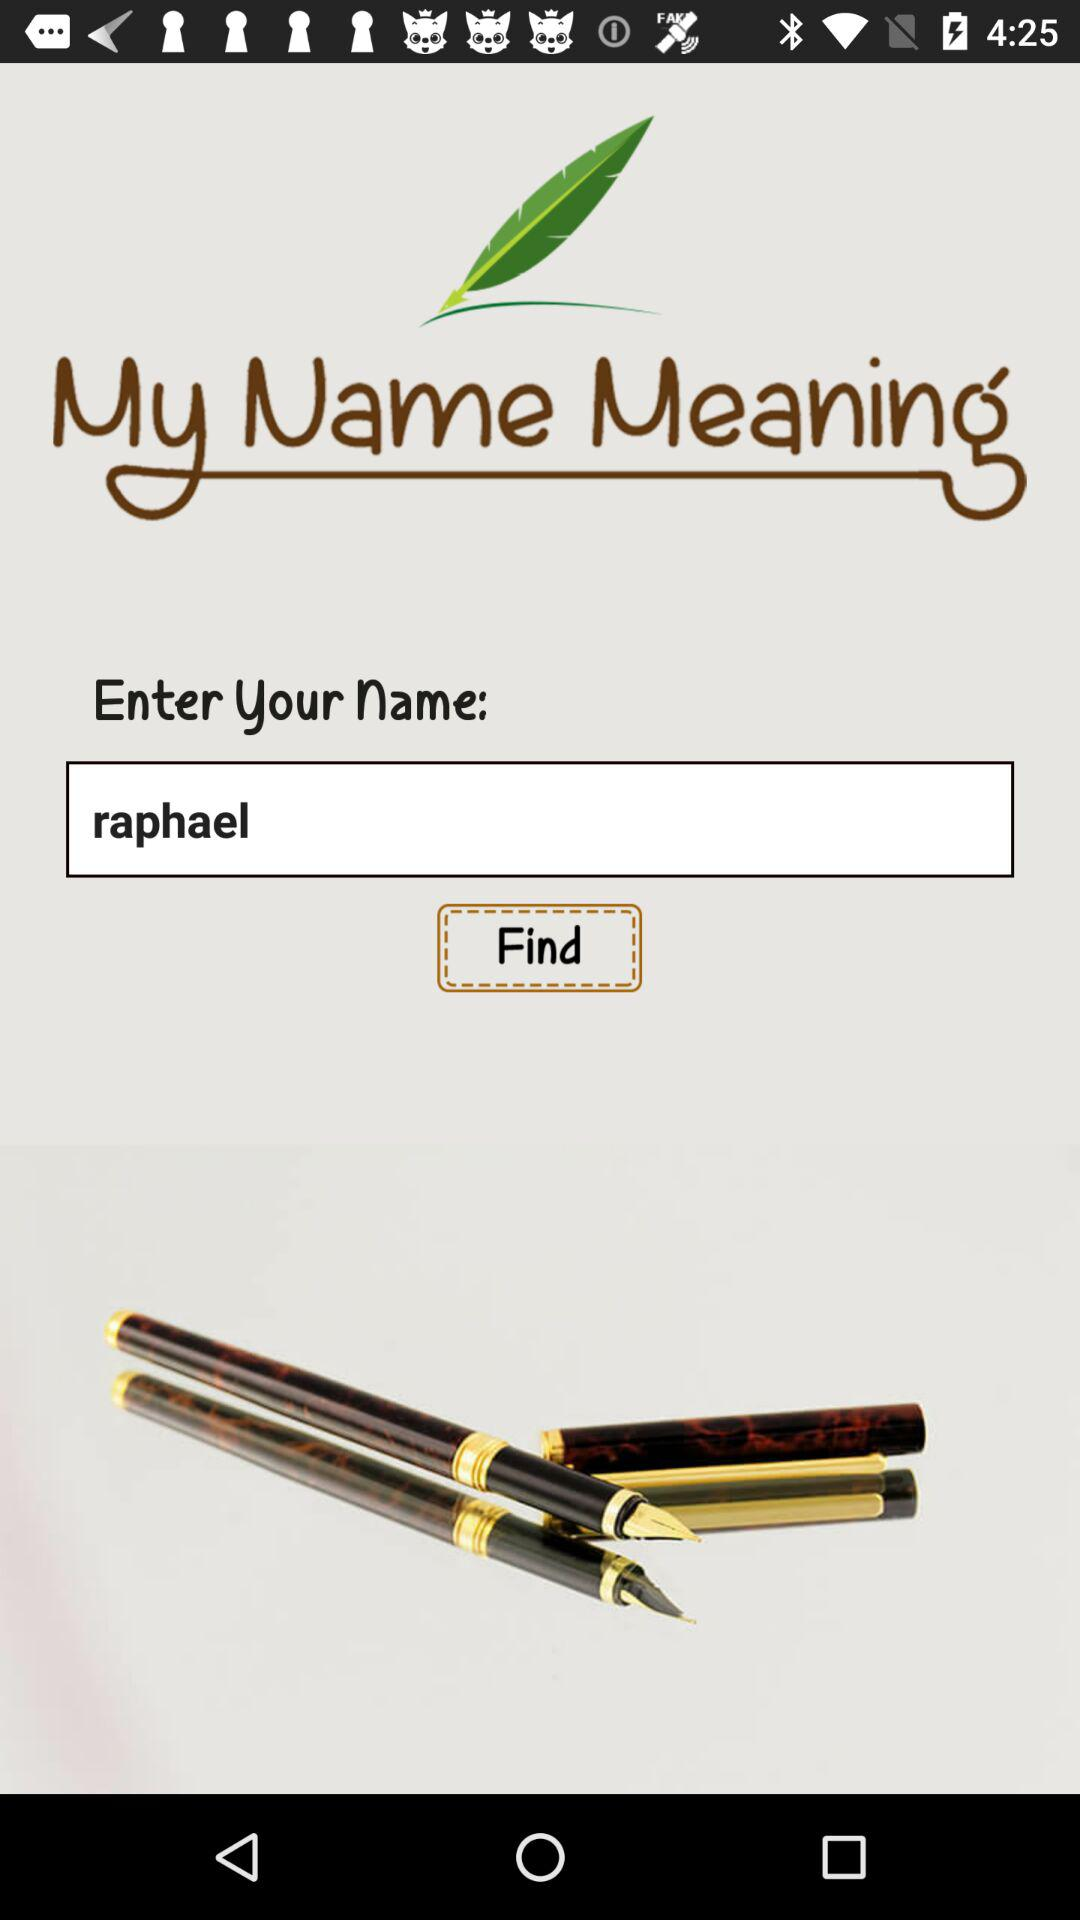What is the entered name? The entered name is Raphael. 